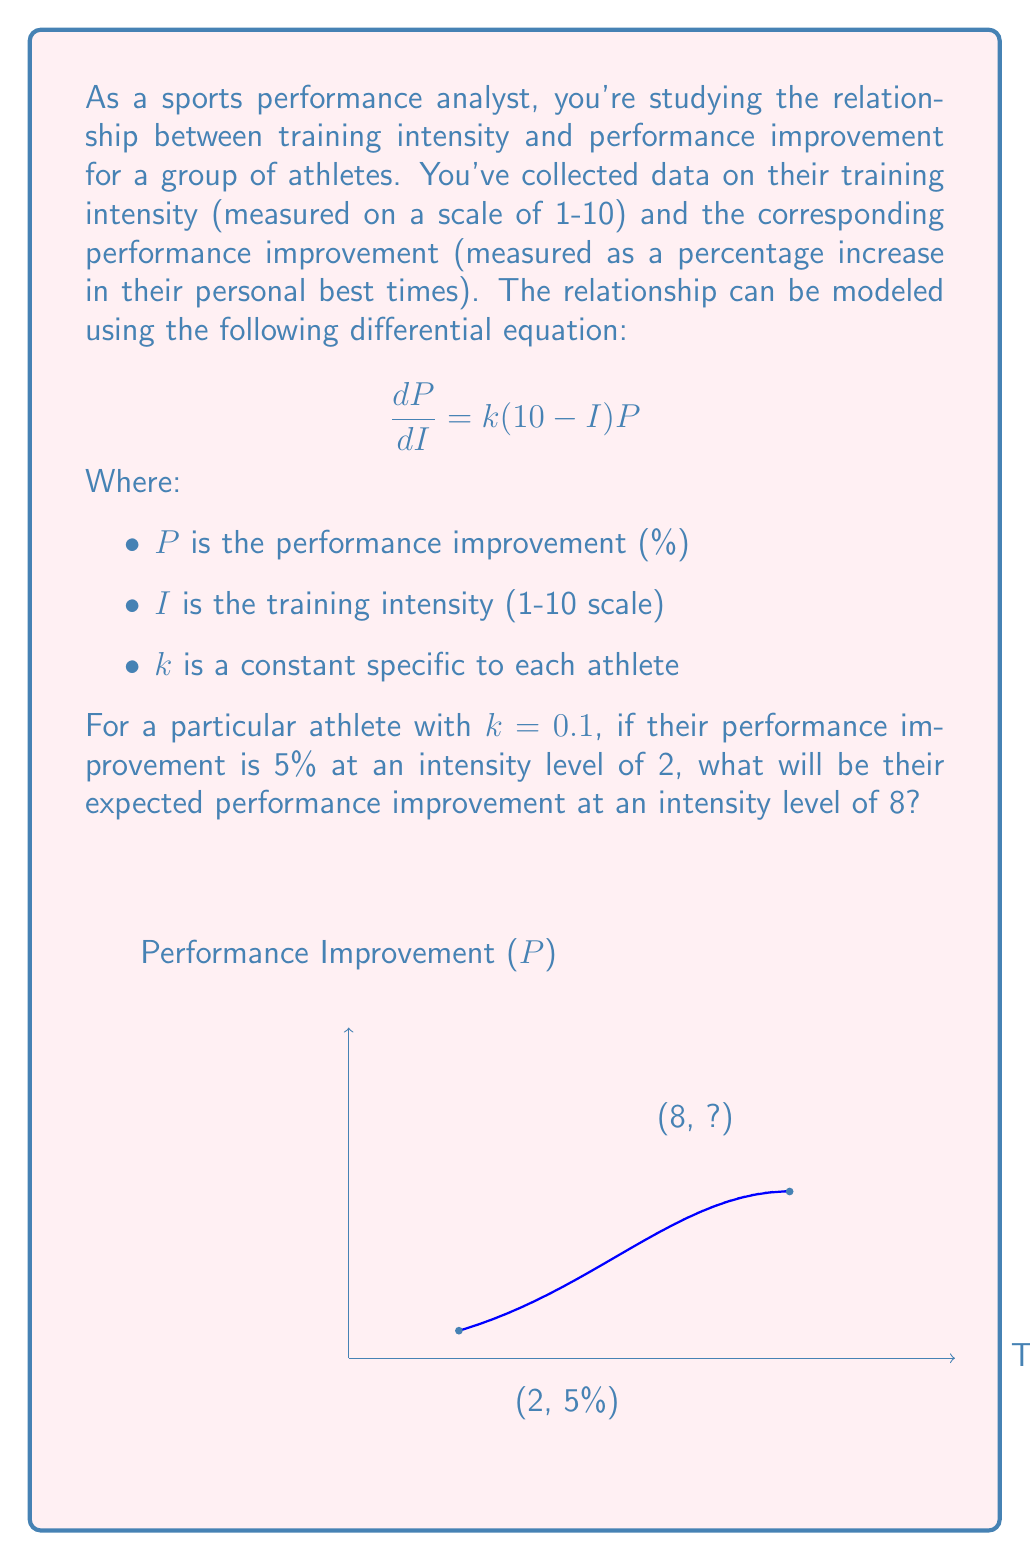Teach me how to tackle this problem. To solve this problem, we need to follow these steps:

1) The given differential equation is:
   $$\frac{dP}{dI} = k(10-I)P$$

2) This is a separable differential equation. We can rewrite it as:
   $$\frac{dP}{P} = k(10-I)dI$$

3) Integrating both sides:
   $$\int \frac{dP}{P} = \int k(10-I)dI$$
   $$\ln|P| = k(10I - \frac{I^2}{2}) + C$$

4) Solving for P:
   $$P = C_1e^{k(10I - \frac{I^2}{2})}$$
   where $C_1 = e^C$ is a new constant.

5) We're given that $P = 5$ when $I = 2$, and $k = 0.1$. Let's use this to find $C_1$:
   $$5 = C_1e^{0.1(10(2) - \frac{2^2}{2})}$$
   $$5 = C_1e^{0.1(20 - 2)} = C_1e^{1.8}$$
   $$C_1 = \frac{5}{e^{1.8}}$$

6) Now our full equation is:
   $$P = \frac{5}{e^{1.8}}e^{0.1(10I - \frac{I^2}{2})}$$

7) To find P when I = 8, we simply plug in 8 for I:
   $$P = \frac{5}{e^{1.8}}e^{0.1(10(8) - \frac{8^2}{2})}$$
   $$= \frac{5}{e^{1.8}}e^{0.1(80 - 32)}$$
   $$= \frac{5}{e^{1.8}}e^{4.8}$$
   $$= 5e^{4.8-1.8} = 5e^3 \approx 24.53$$

Therefore, the expected performance improvement at an intensity level of 8 is approximately 24.53%.
Answer: 24.53% 